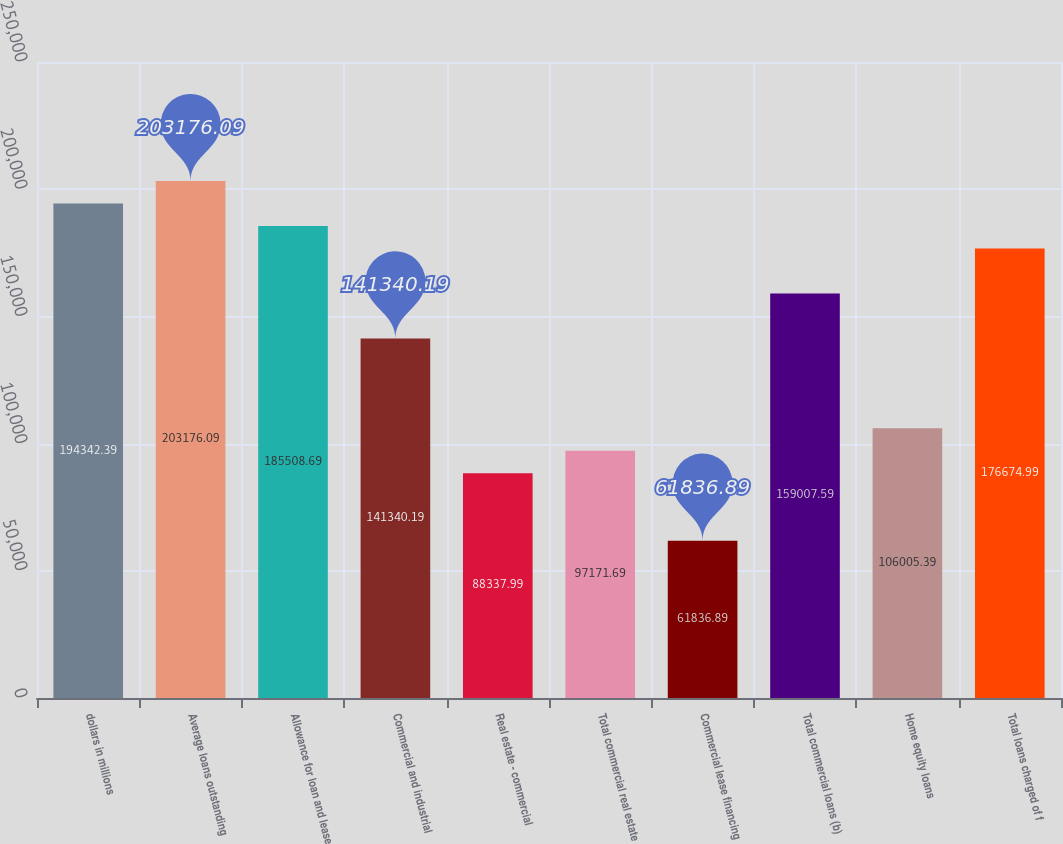<chart> <loc_0><loc_0><loc_500><loc_500><bar_chart><fcel>dollars in millions<fcel>Average loans outstanding<fcel>Allowance for loan and lease<fcel>Commercial and industrial<fcel>Real estate - commercial<fcel>Total commercial real estate<fcel>Commercial lease financing<fcel>Total commercial loans (b)<fcel>Home equity loans<fcel>Total loans charged of f<nl><fcel>194342<fcel>203176<fcel>185509<fcel>141340<fcel>88338<fcel>97171.7<fcel>61836.9<fcel>159008<fcel>106005<fcel>176675<nl></chart> 